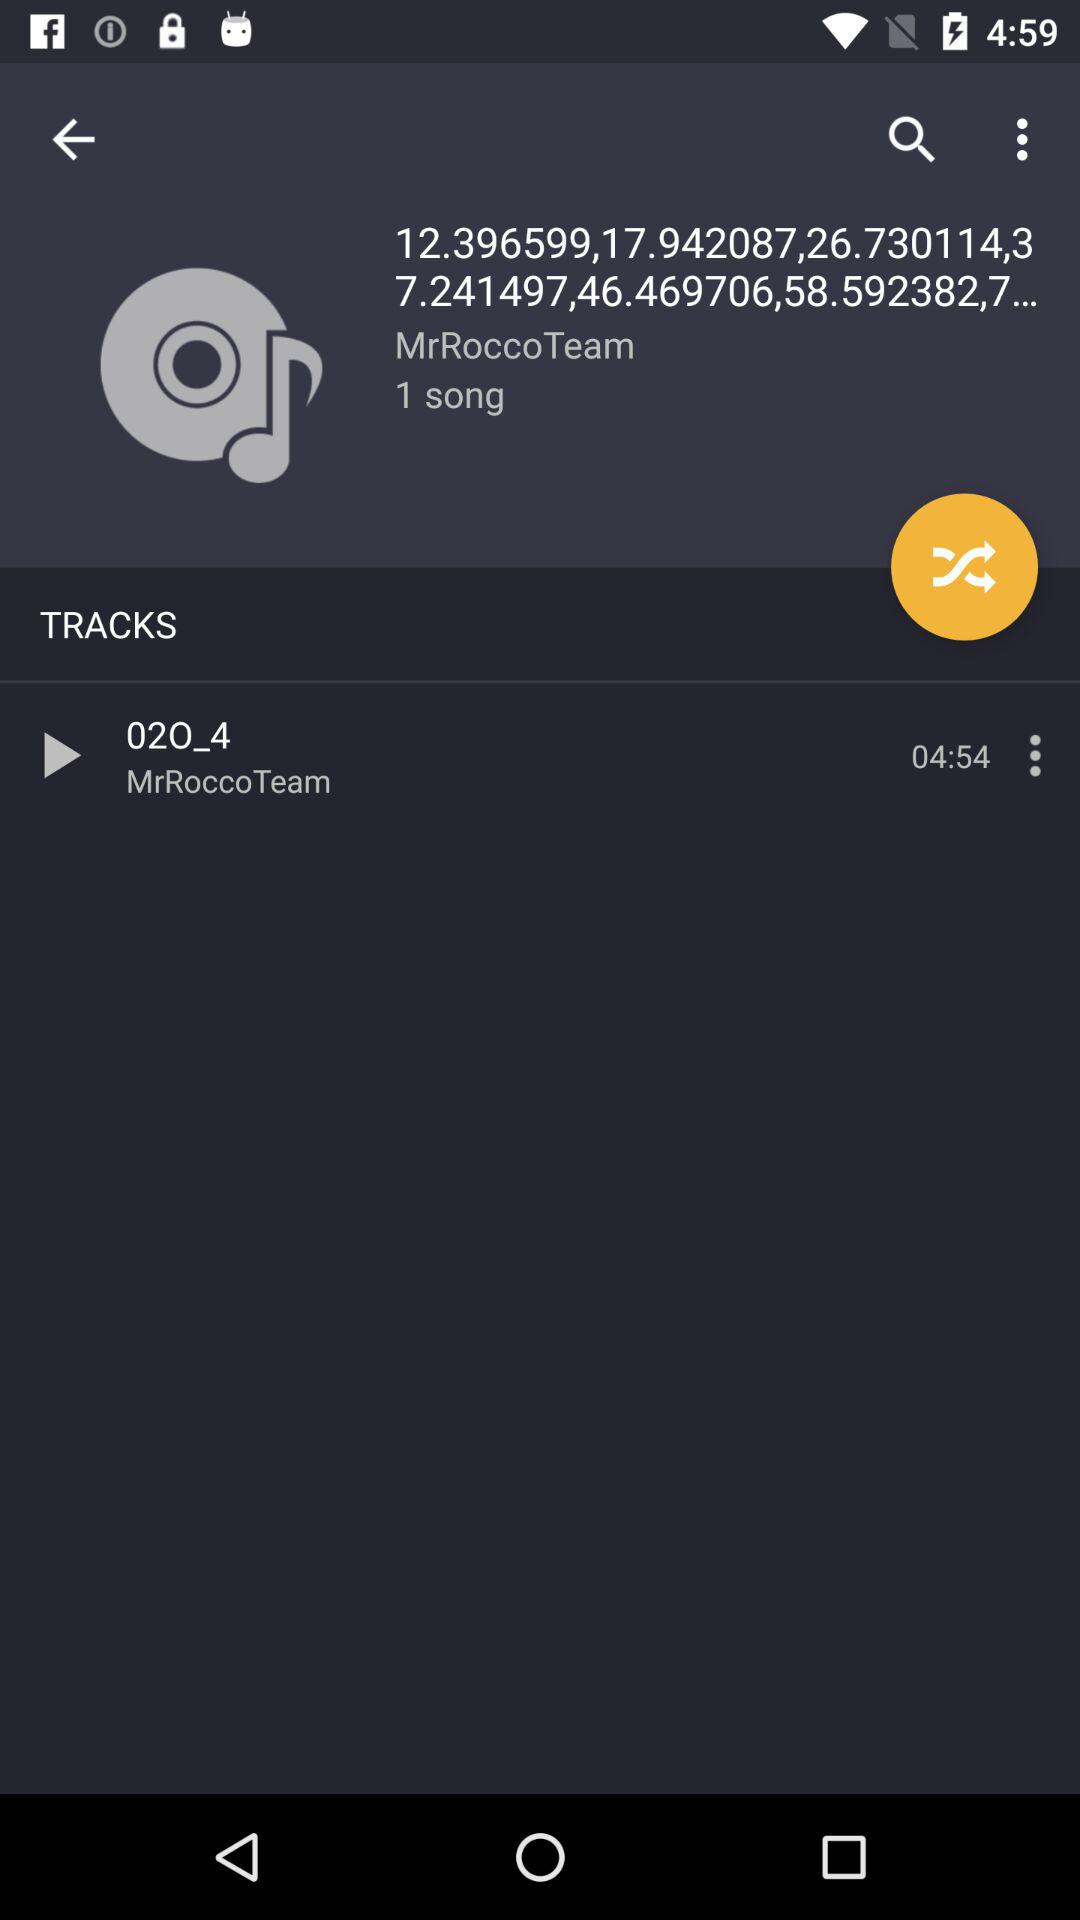How many songs are there in total?
Answer the question using a single word or phrase. 1 